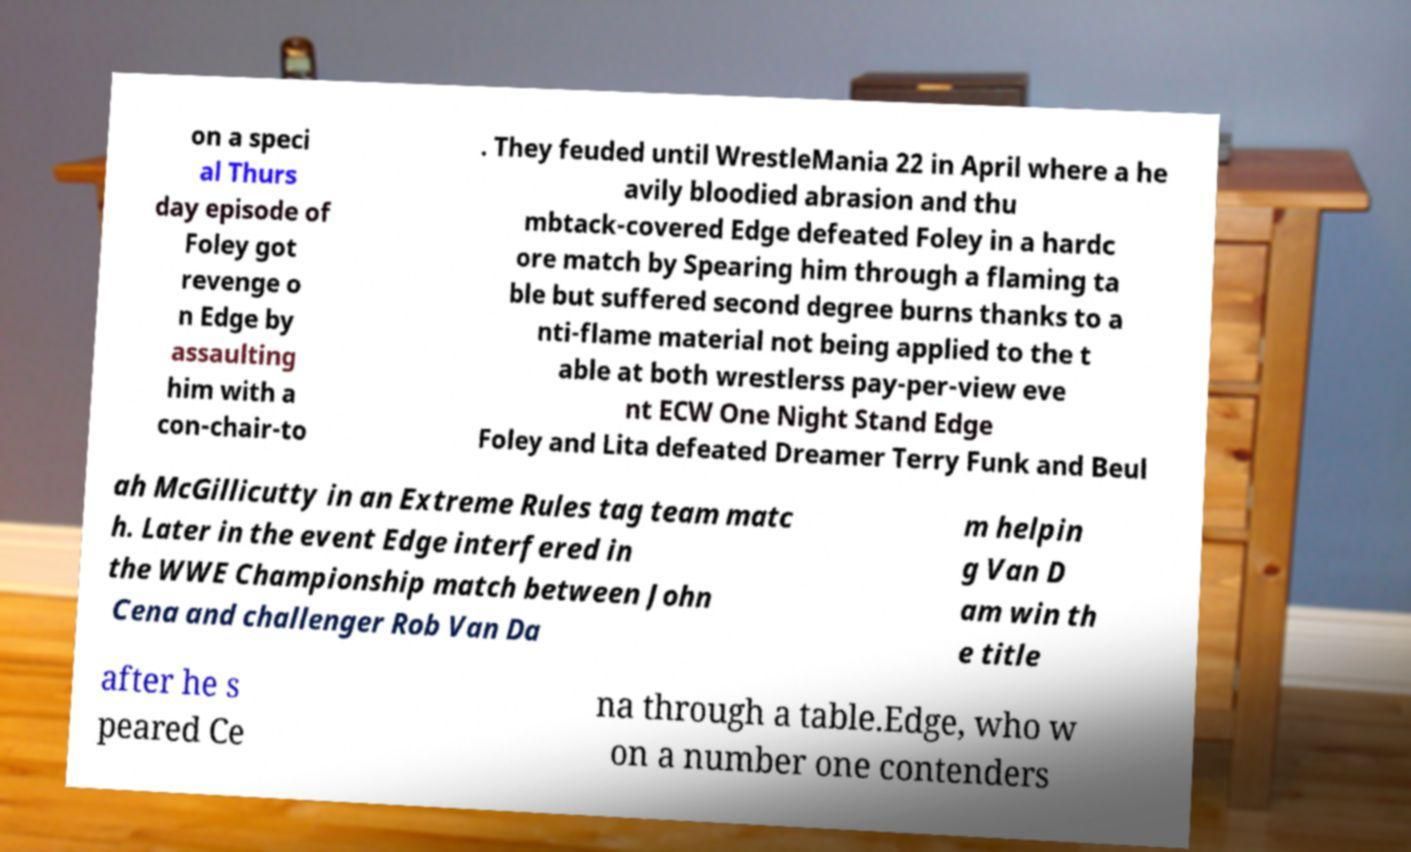Could you extract and type out the text from this image? on a speci al Thurs day episode of Foley got revenge o n Edge by assaulting him with a con-chair-to . They feuded until WrestleMania 22 in April where a he avily bloodied abrasion and thu mbtack-covered Edge defeated Foley in a hardc ore match by Spearing him through a flaming ta ble but suffered second degree burns thanks to a nti-flame material not being applied to the t able at both wrestlerss pay-per-view eve nt ECW One Night Stand Edge Foley and Lita defeated Dreamer Terry Funk and Beul ah McGillicutty in an Extreme Rules tag team matc h. Later in the event Edge interfered in the WWE Championship match between John Cena and challenger Rob Van Da m helpin g Van D am win th e title after he s peared Ce na through a table.Edge, who w on a number one contenders 